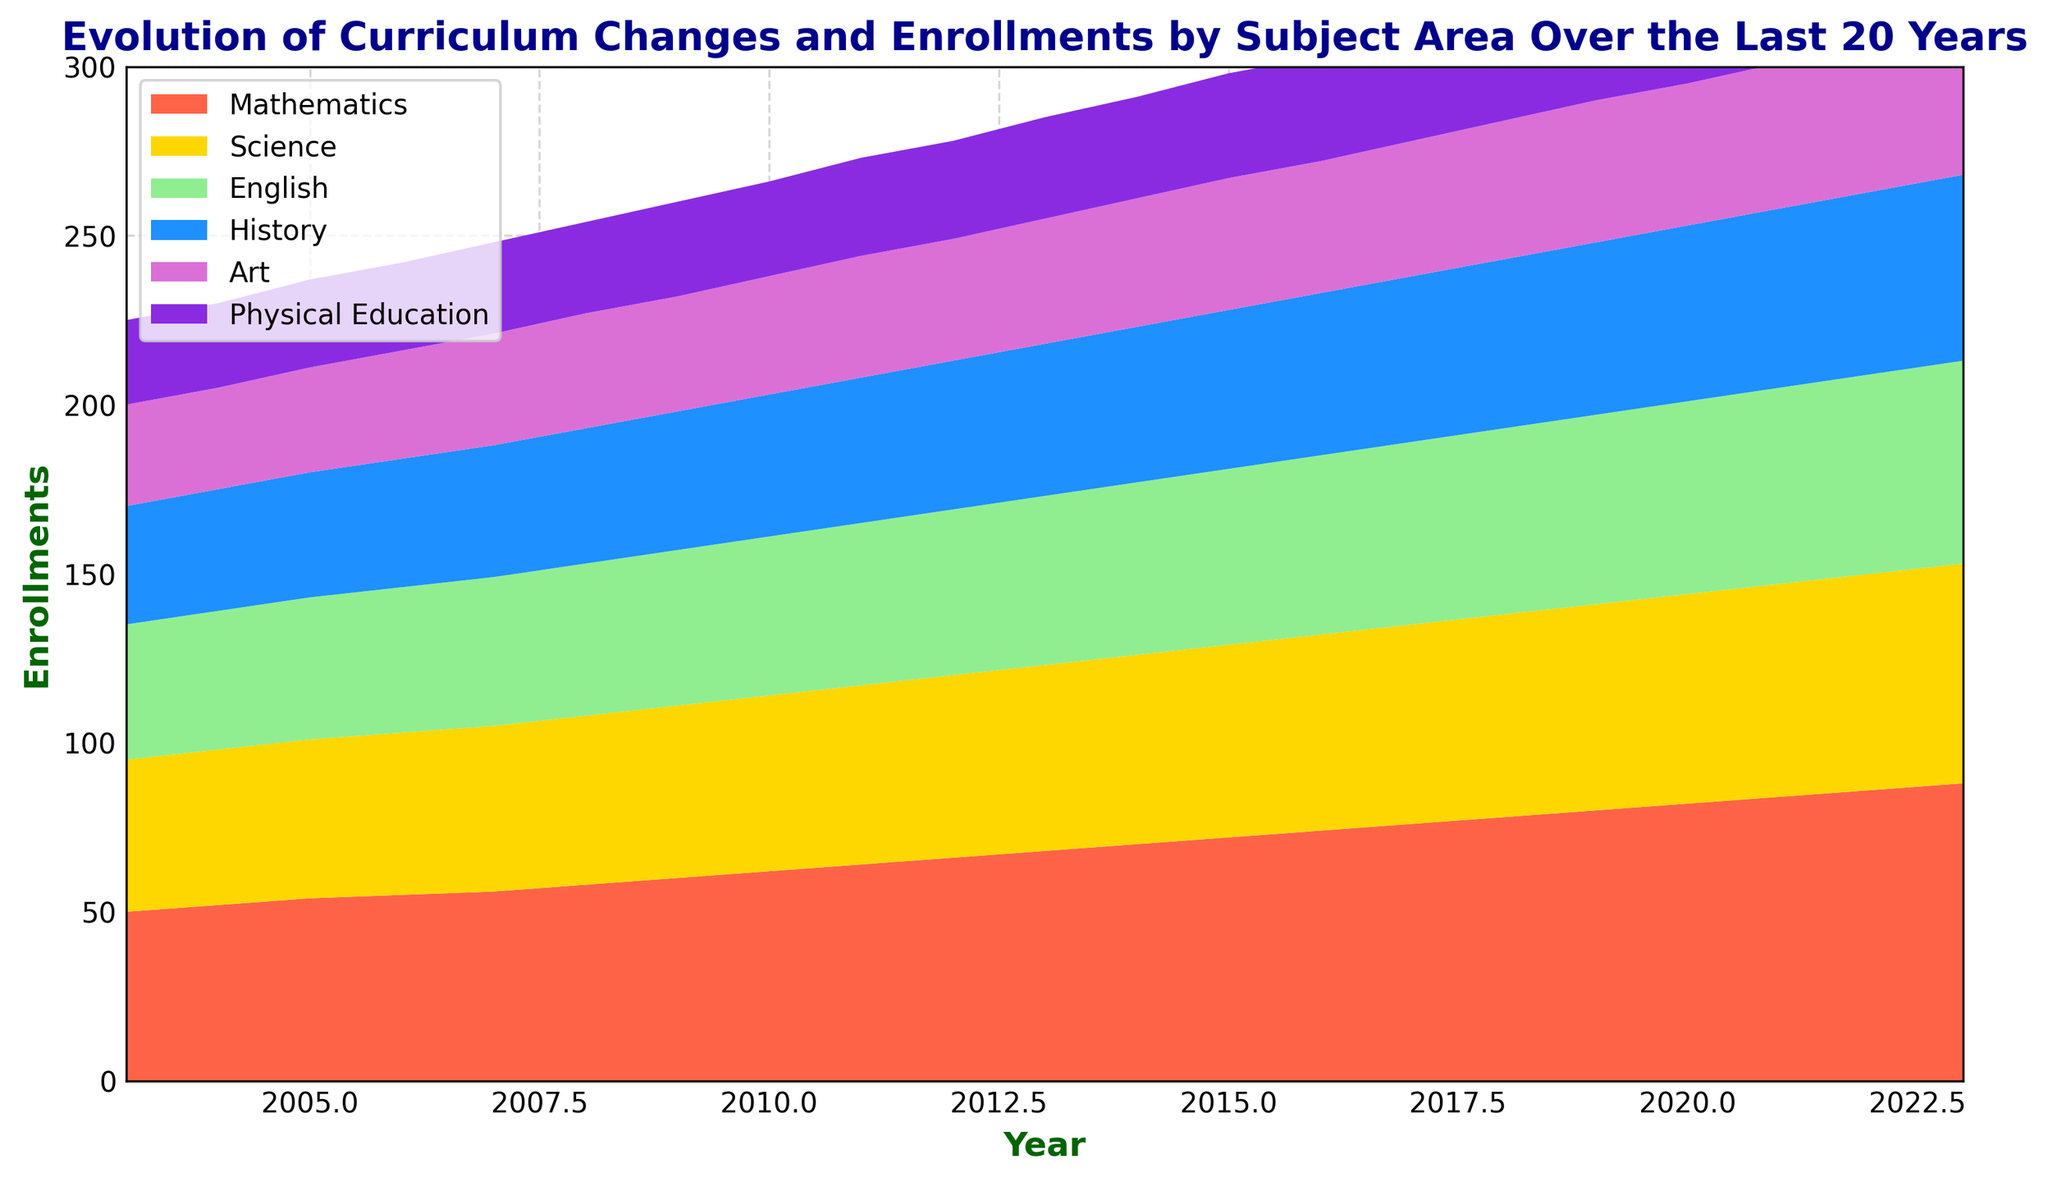What is the trend in Mathematics enrollments over the years? The area chart shows an increasing trend in Mathematics enrollments from 2003 to 2023, rising from 50 in 2003 to 88 in 2023.
Answer: Increasing trend In which year did Science enrollments first reach 50? By observing the Science segment of the area chart, it can be identified that Science enrollments reached 50 in the year 2008.
Answer: 2008 Which subject had the highest enrollment in 2023, and what was the enrollment number? By examining the height of the areas in 2023, Mathematics is the highest with an enrollment of 88.
Answer: Mathematics, 88 Compare the enrollment numbers for Art and Physical Education in 2018. Which was higher and by how much? In 2018, the chart shows Art enrollments at 41 and Physical Education at 32. The difference is 41 - 32 = 9.
Answer: Art, by 9 What is the total enrollment across all subjects in 2015? Sum the values for all subjects in 2015: Mathematics (72), Science (57), English (52), History (47), Art (39), and Physical Education (31). The total is 72 + 57 + 52 + 47 + 39 + 31 = 298.
Answer: 298 Which two subjects had the smallest difference in enrollments in 2020? In 2020, compare the enrollments: Mathematics (82), Science (62), English (57), History (52), Art (42), Physical Education (33). The smallest difference is between English (57) and History (52), with a difference of 57 - 52 = 5.
Answer: English and History, 5 How much did Mathematics enrollments increase from 2003 to 2023? The chart shows Mathematics enrollments increased from 50 in 2003 to 88 in 2023. The increase is 88 - 50 = 38.
Answer: 38 In what year did History enrollments surpass 40? Referring to the chart, History enrollments surpassed 40 in the year 2009.
Answer: 2009 What is the approximate cumulative enrollment for English and Science in 2012? Sum the values for English (49) and Science (54) in 2012. The total is 49 + 54 = 103.
Answer: 103 Which subject shows the least variation in enrollments over the 20 years? By observing the stability in the area size, Physical Education shows the least variation, fluctuating only between 25 and 35.
Answer: Physical Education 